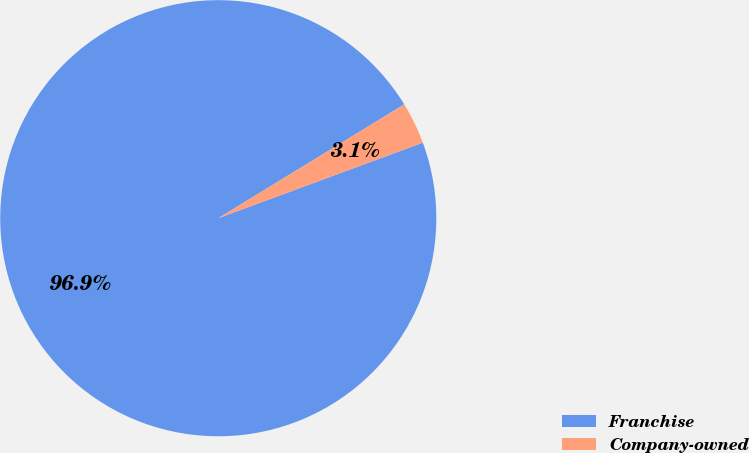Convert chart to OTSL. <chart><loc_0><loc_0><loc_500><loc_500><pie_chart><fcel>Franchise<fcel>Company-owned<nl><fcel>96.89%<fcel>3.11%<nl></chart> 